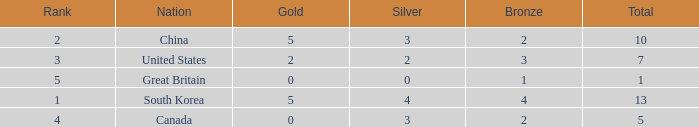Parse the table in full. {'header': ['Rank', 'Nation', 'Gold', 'Silver', 'Bronze', 'Total'], 'rows': [['2', 'China', '5', '3', '2', '10'], ['3', 'United States', '2', '2', '3', '7'], ['5', 'Great Britain', '0', '0', '1', '1'], ['1', 'South Korea', '5', '4', '4', '13'], ['4', 'Canada', '0', '3', '2', '5']]} What is the lowest Rank, when Nation is Great Britain, and when Bronze is less than 1? None. 